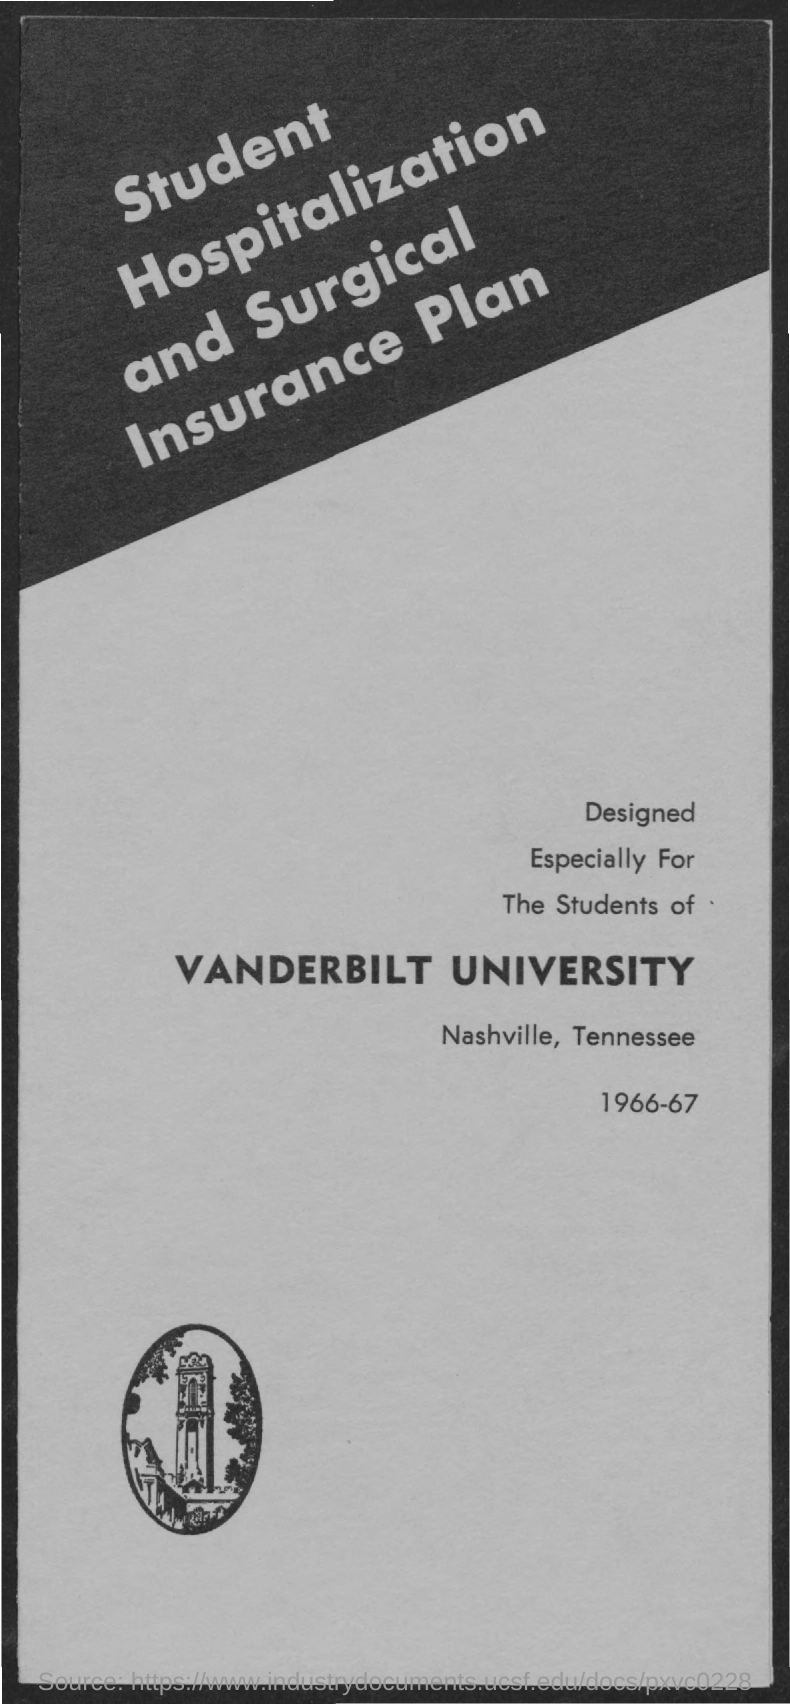Specify some key components in this picture. The named entity "Insurance Plan" has been recognized as a common noun, and the specific name of the plan "Student Hospitalization and Surgical Insurance Plan" has been recognized as a proper noun. What is the year mentioned at the bottom of the page? It is 1966-67. Vanderbilt University is the name of the university. 